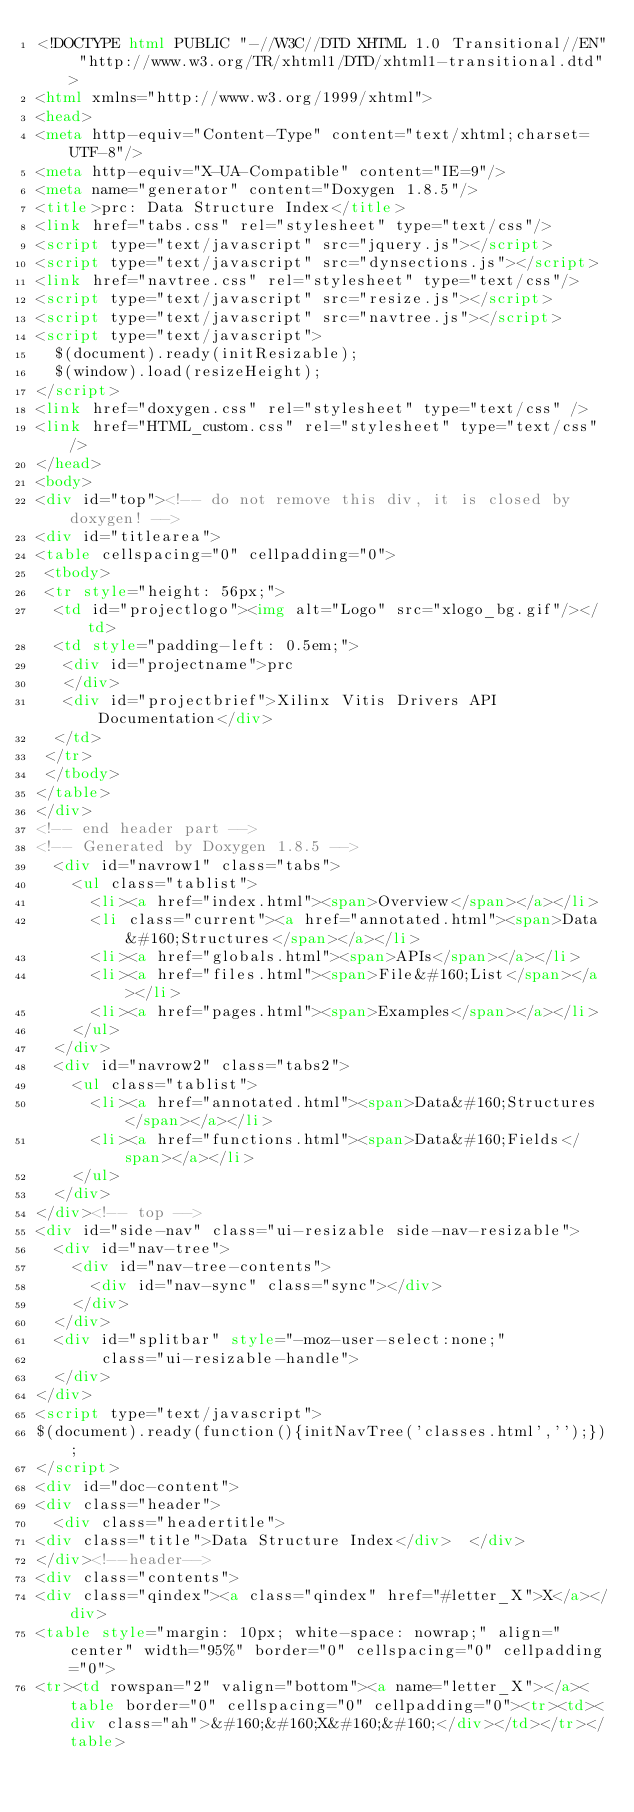<code> <loc_0><loc_0><loc_500><loc_500><_HTML_><!DOCTYPE html PUBLIC "-//W3C//DTD XHTML 1.0 Transitional//EN" "http://www.w3.org/TR/xhtml1/DTD/xhtml1-transitional.dtd">
<html xmlns="http://www.w3.org/1999/xhtml">
<head>
<meta http-equiv="Content-Type" content="text/xhtml;charset=UTF-8"/>
<meta http-equiv="X-UA-Compatible" content="IE=9"/>
<meta name="generator" content="Doxygen 1.8.5"/>
<title>prc: Data Structure Index</title>
<link href="tabs.css" rel="stylesheet" type="text/css"/>
<script type="text/javascript" src="jquery.js"></script>
<script type="text/javascript" src="dynsections.js"></script>
<link href="navtree.css" rel="stylesheet" type="text/css"/>
<script type="text/javascript" src="resize.js"></script>
<script type="text/javascript" src="navtree.js"></script>
<script type="text/javascript">
  $(document).ready(initResizable);
  $(window).load(resizeHeight);
</script>
<link href="doxygen.css" rel="stylesheet" type="text/css" />
<link href="HTML_custom.css" rel="stylesheet" type="text/css"/>
</head>
<body>
<div id="top"><!-- do not remove this div, it is closed by doxygen! -->
<div id="titlearea">
<table cellspacing="0" cellpadding="0">
 <tbody>
 <tr style="height: 56px;">
  <td id="projectlogo"><img alt="Logo" src="xlogo_bg.gif"/></td>
  <td style="padding-left: 0.5em;">
   <div id="projectname">prc
   </div>
   <div id="projectbrief">Xilinx Vitis Drivers API Documentation</div>
  </td>
 </tr>
 </tbody>
</table>
</div>
<!-- end header part -->
<!-- Generated by Doxygen 1.8.5 -->
  <div id="navrow1" class="tabs">
    <ul class="tablist">
      <li><a href="index.html"><span>Overview</span></a></li>
      <li class="current"><a href="annotated.html"><span>Data&#160;Structures</span></a></li>
      <li><a href="globals.html"><span>APIs</span></a></li>
      <li><a href="files.html"><span>File&#160;List</span></a></li>
      <li><a href="pages.html"><span>Examples</span></a></li>
    </ul>
  </div>
  <div id="navrow2" class="tabs2">
    <ul class="tablist">
      <li><a href="annotated.html"><span>Data&#160;Structures</span></a></li>
      <li><a href="functions.html"><span>Data&#160;Fields</span></a></li>
    </ul>
  </div>
</div><!-- top -->
<div id="side-nav" class="ui-resizable side-nav-resizable">
  <div id="nav-tree">
    <div id="nav-tree-contents">
      <div id="nav-sync" class="sync"></div>
    </div>
  </div>
  <div id="splitbar" style="-moz-user-select:none;" 
       class="ui-resizable-handle">
  </div>
</div>
<script type="text/javascript">
$(document).ready(function(){initNavTree('classes.html','');});
</script>
<div id="doc-content">
<div class="header">
  <div class="headertitle">
<div class="title">Data Structure Index</div>  </div>
</div><!--header-->
<div class="contents">
<div class="qindex"><a class="qindex" href="#letter_X">X</a></div>
<table style="margin: 10px; white-space: nowrap;" align="center" width="95%" border="0" cellspacing="0" cellpadding="0">
<tr><td rowspan="2" valign="bottom"><a name="letter_X"></a><table border="0" cellspacing="0" cellpadding="0"><tr><td><div class="ah">&#160;&#160;X&#160;&#160;</div></td></tr></table></code> 